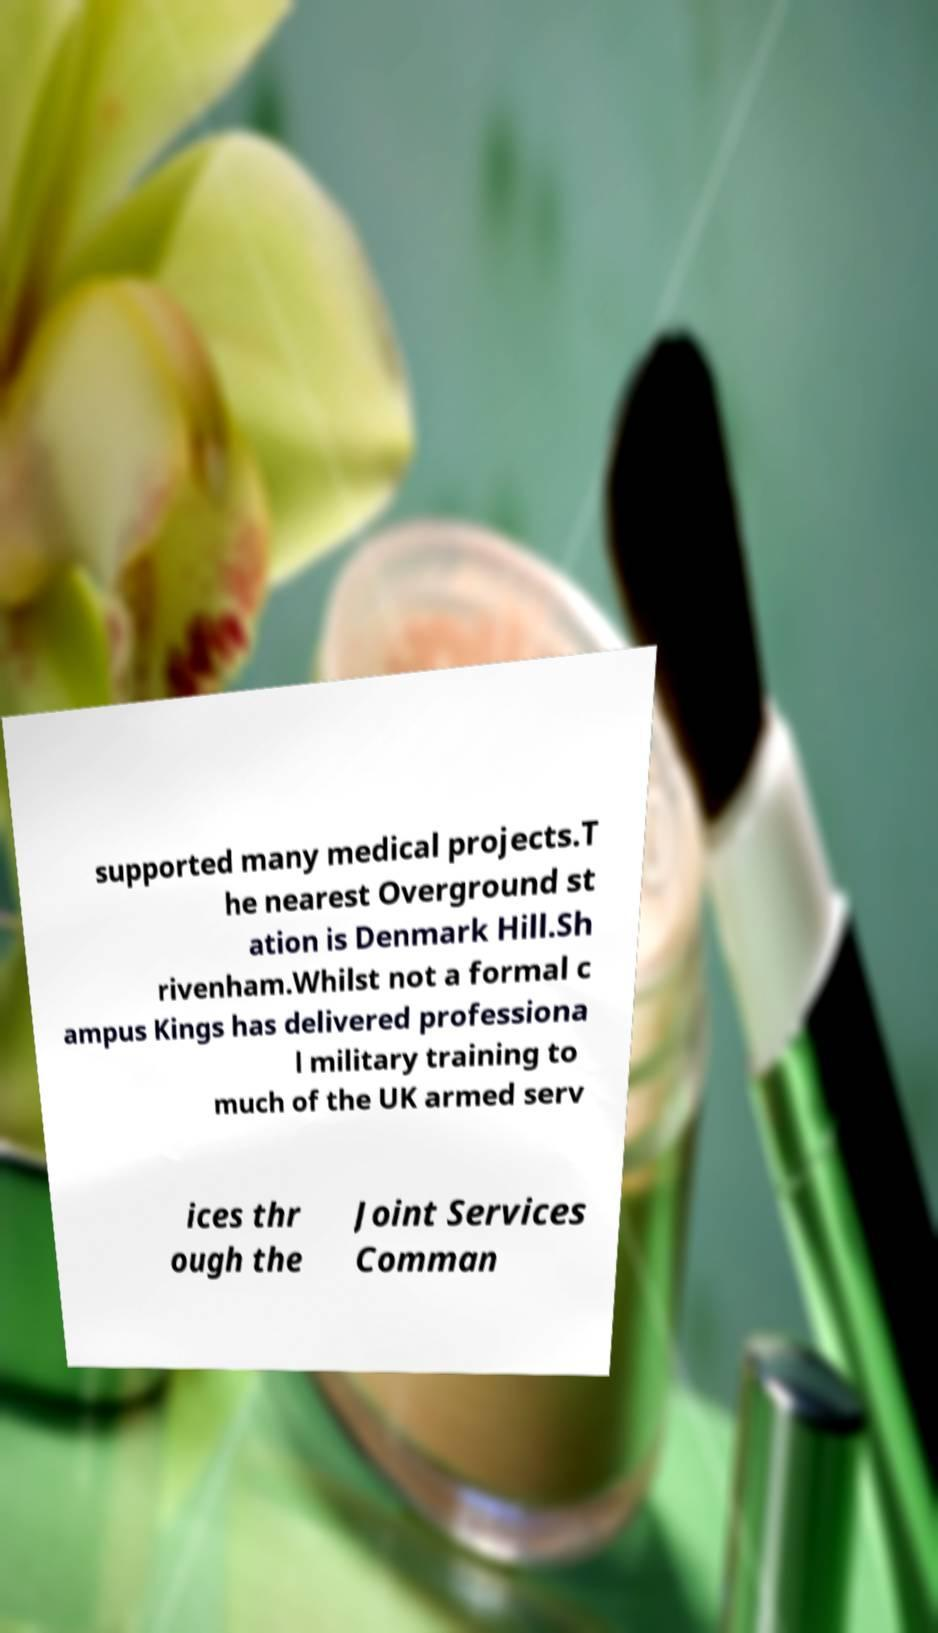Can you read and provide the text displayed in the image?This photo seems to have some interesting text. Can you extract and type it out for me? supported many medical projects.T he nearest Overground st ation is Denmark Hill.Sh rivenham.Whilst not a formal c ampus Kings has delivered professiona l military training to much of the UK armed serv ices thr ough the Joint Services Comman 